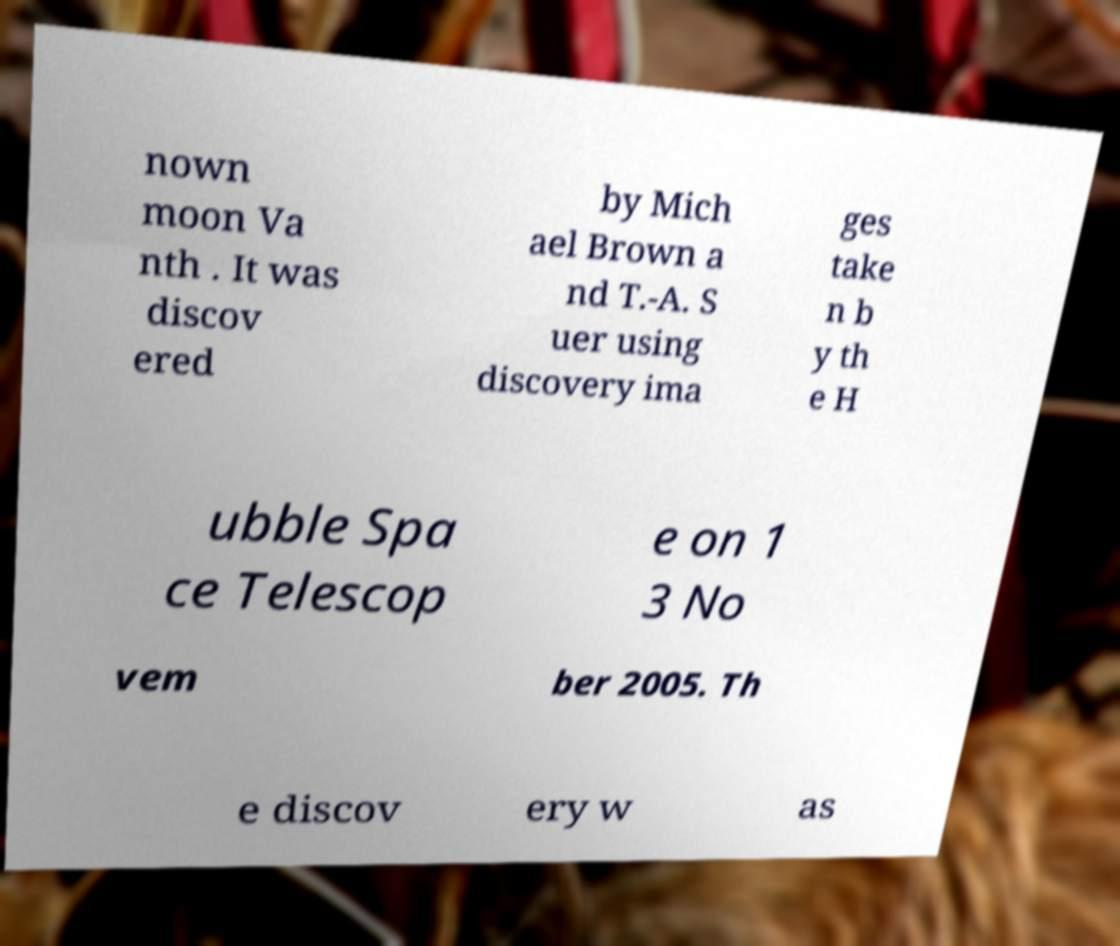Can you accurately transcribe the text from the provided image for me? nown moon Va nth . It was discov ered by Mich ael Brown a nd T.-A. S uer using discovery ima ges take n b y th e H ubble Spa ce Telescop e on 1 3 No vem ber 2005. Th e discov ery w as 